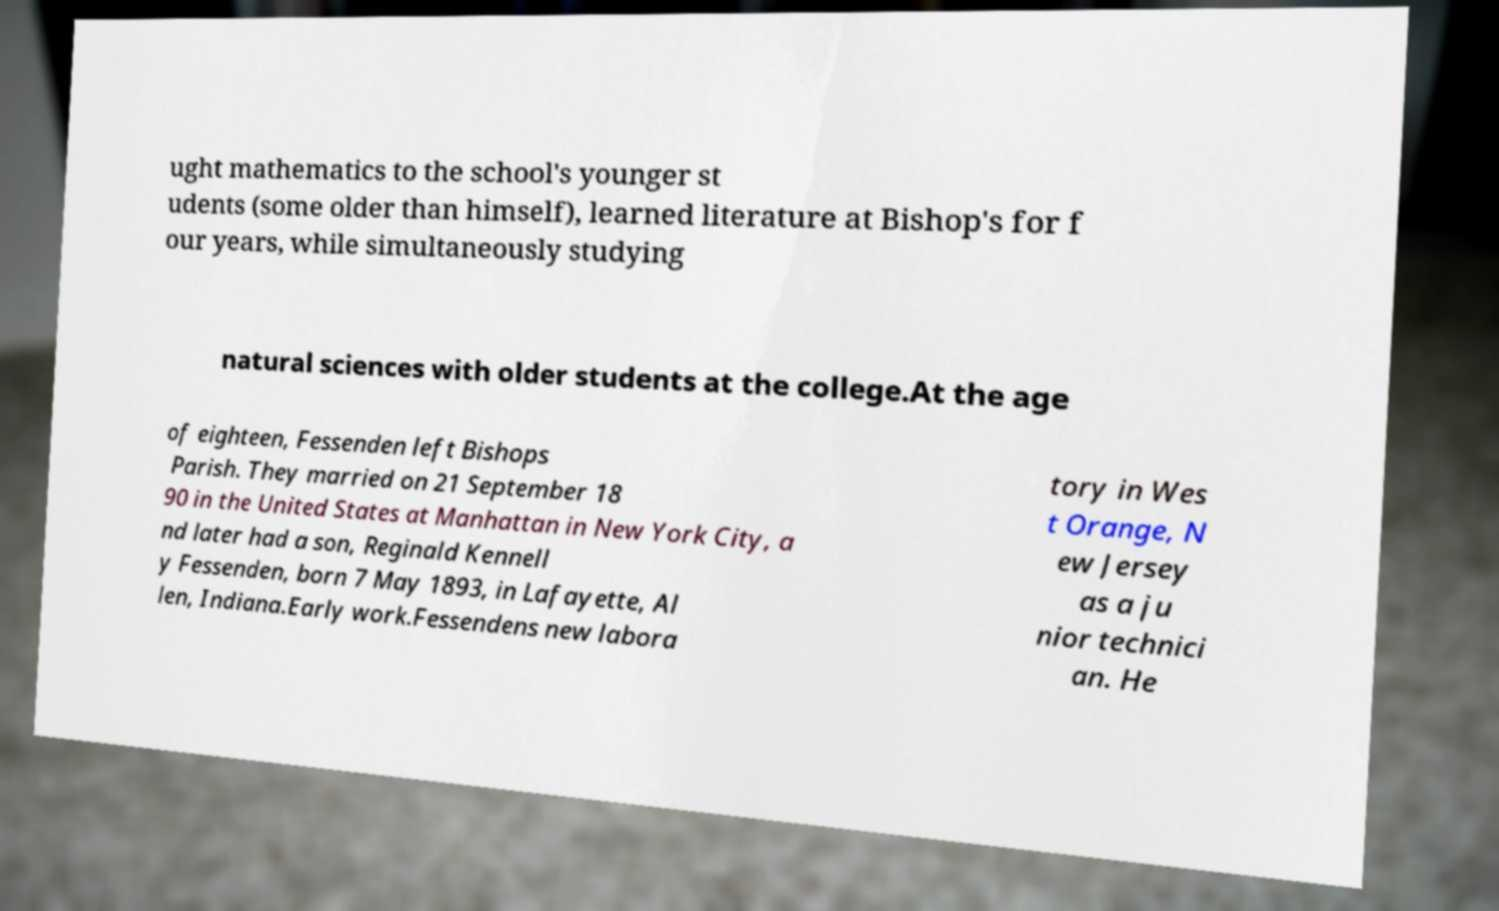Can you read and provide the text displayed in the image?This photo seems to have some interesting text. Can you extract and type it out for me? ught mathematics to the school's younger st udents (some older than himself), learned literature at Bishop's for f our years, while simultaneously studying natural sciences with older students at the college.At the age of eighteen, Fessenden left Bishops Parish. They married on 21 September 18 90 in the United States at Manhattan in New York City, a nd later had a son, Reginald Kennell y Fessenden, born 7 May 1893, in Lafayette, Al len, Indiana.Early work.Fessendens new labora tory in Wes t Orange, N ew Jersey as a ju nior technici an. He 